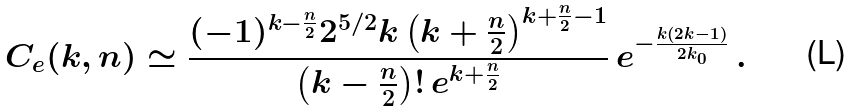Convert formula to latex. <formula><loc_0><loc_0><loc_500><loc_500>C _ { e } ( k , n ) \simeq \frac { ( - 1 ) ^ { k - \frac { n } { 2 } } 2 ^ { 5 / 2 } k \left ( k + \frac { n } { 2 } \right ) ^ { k + \frac { n } { 2 } - 1 } } { \left ( k - \frac { n } { 2 } \right ) ! \, e ^ { k + \frac { n } { 2 } } } \, e ^ { - \frac { k ( 2 k - 1 ) } { 2 k _ { 0 } } } \, .</formula> 